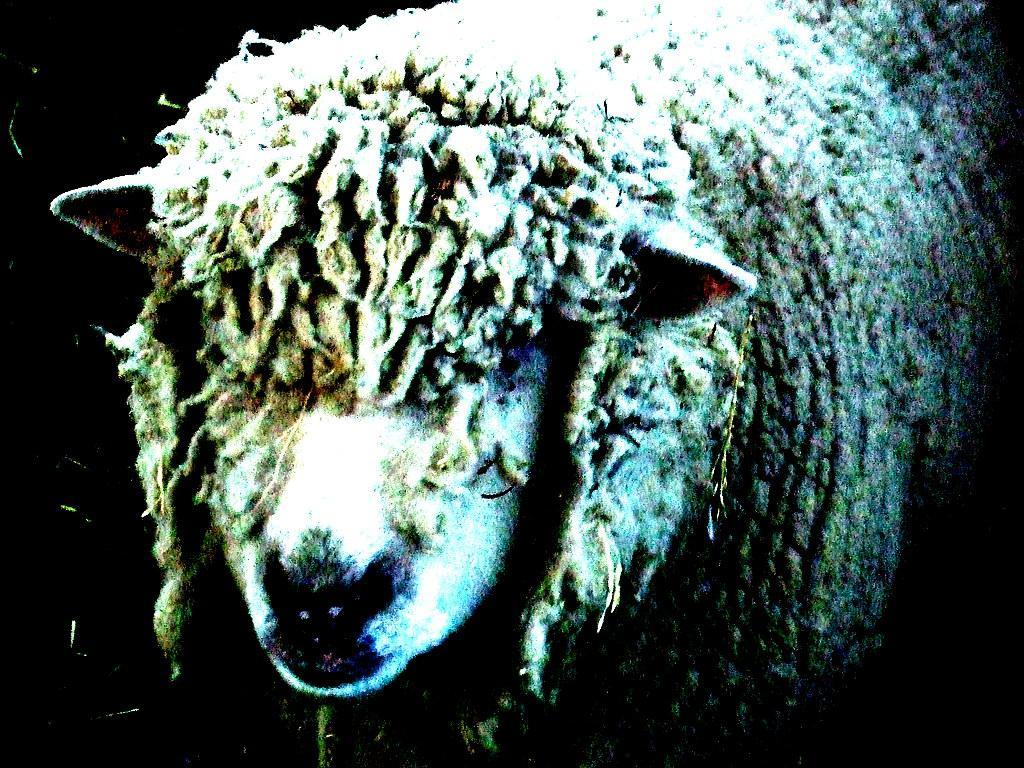What is the main subject of the image? There is an animal in the center of the image. Can you describe the background of the image? The background of the image is dark. What type of trains can be seen in the image? There are no trains present in the image; it features an animal in the center and a dark background. Is the animal sitting on a throne in the image? There is no throne present in the image; it only features an animal and a dark background. 